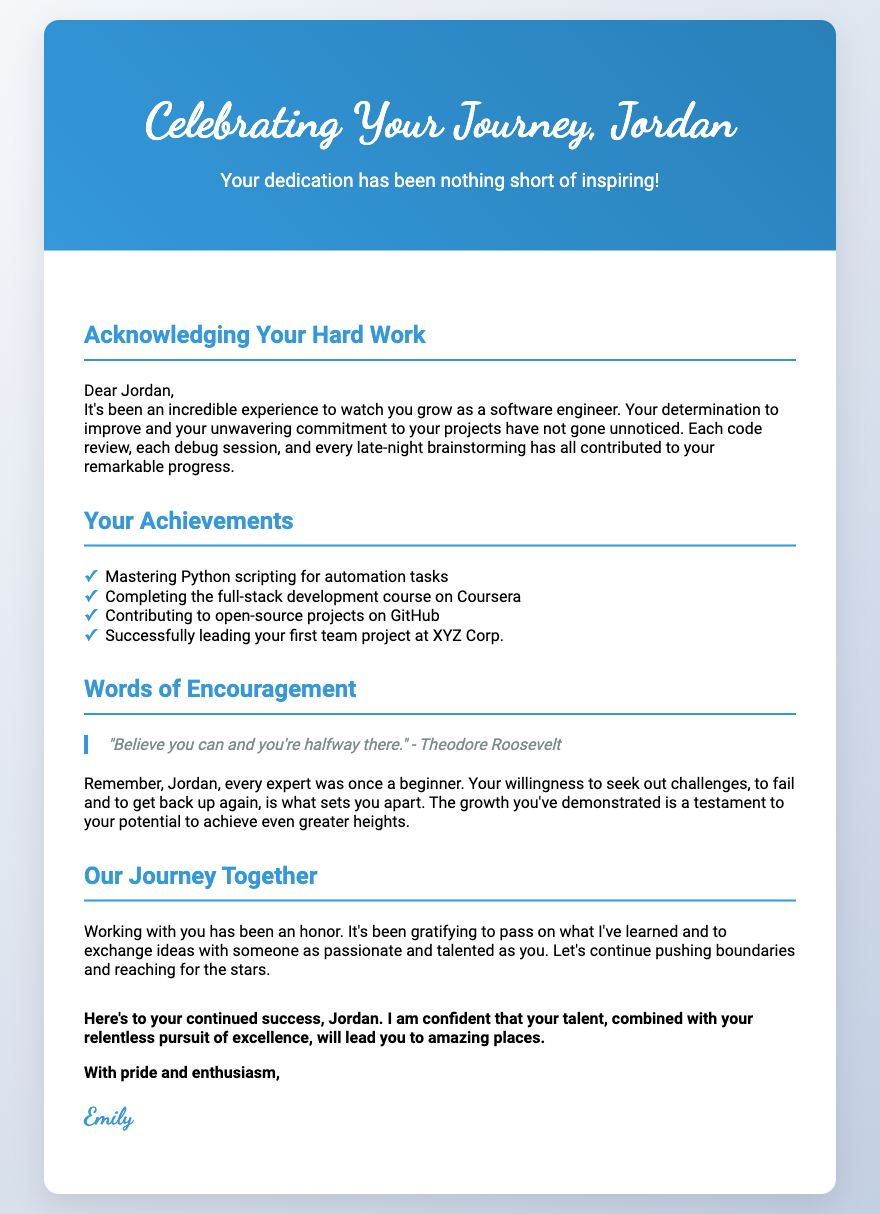What is the title of the card? The title is located at the top of the card and reads "Celebrating Your Journey, Jordan."
Answer: Celebrating Your Journey, Jordan Who is the card addressed to? The card begins with "Dear Jordan," indicating that it is addressed to Jordan.
Answer: Jordan How many achievements are listed in the document? The document lists four specific achievements under the "Your Achievements" section.
Answer: Four What is one of the notable quotes included in the card? The card features a quote from Theodore Roosevelt which reads, "Believe you can and you're halfway there."
Answer: Believe you can and you're halfway there Who is the author of the card? The signature at the end of the card indicates that the author is Emily.
Answer: Emily What is the main theme of the card? The main theme focuses on mentorship appreciation, celebrating dedication and growth.
Answer: Mentorship appreciation What color scheme is used for the card cover? The card cover utilizes a gradient of blue colors, specifically #3498db and #2980b9.
Answer: Blue gradient Why does the author feel honored? The author expresses honor in the card due to the gratifying experience of passing knowledge and exchanging ideas with Jordan.
Answer: Gratifying experience What does the author encourage Jordan to continue doing? The author encourages Jordan to keep pushing boundaries and reaching for the stars.
Answer: Pushing boundaries and reaching for the stars 